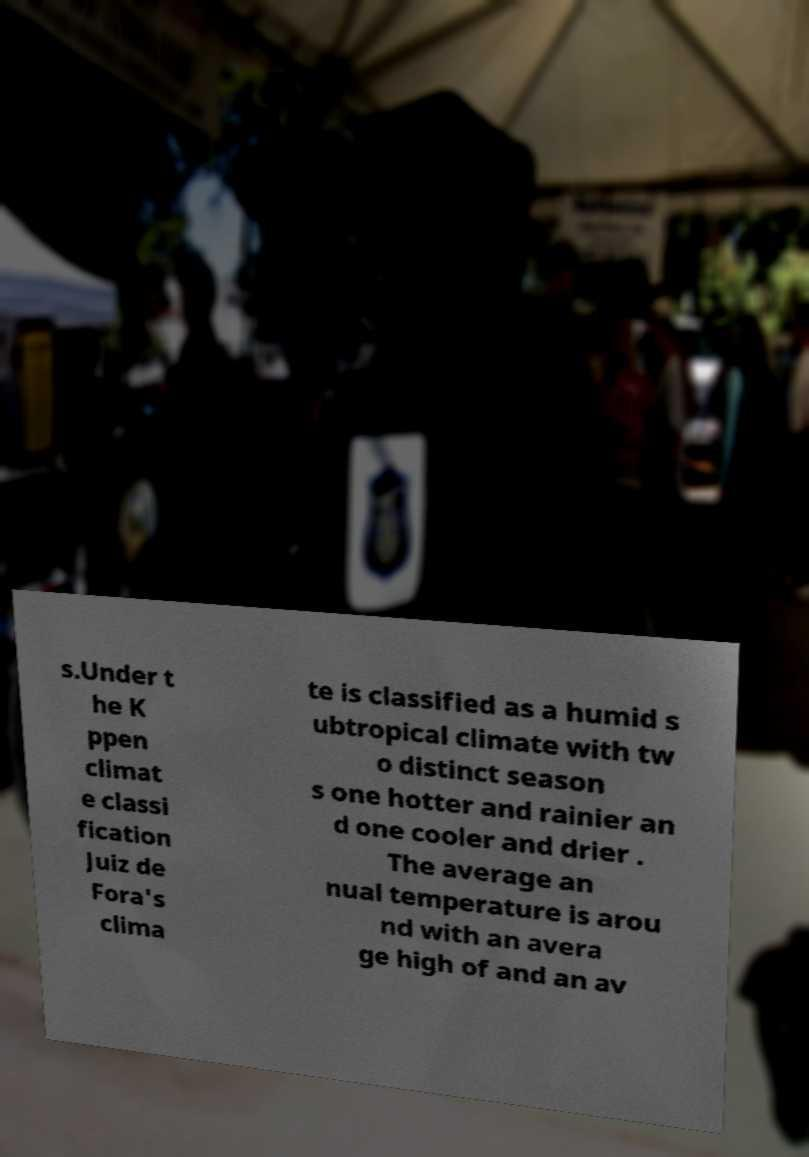There's text embedded in this image that I need extracted. Can you transcribe it verbatim? s.Under t he K ppen climat e classi fication Juiz de Fora's clima te is classified as a humid s ubtropical climate with tw o distinct season s one hotter and rainier an d one cooler and drier . The average an nual temperature is arou nd with an avera ge high of and an av 